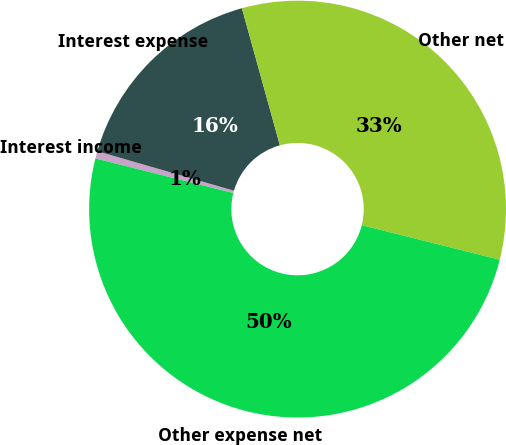<chart> <loc_0><loc_0><loc_500><loc_500><pie_chart><fcel>Interest income<fcel>Interest expense<fcel>Other net<fcel>Other expense net<nl><fcel>0.57%<fcel>16.22%<fcel>33.21%<fcel>50.0%<nl></chart> 